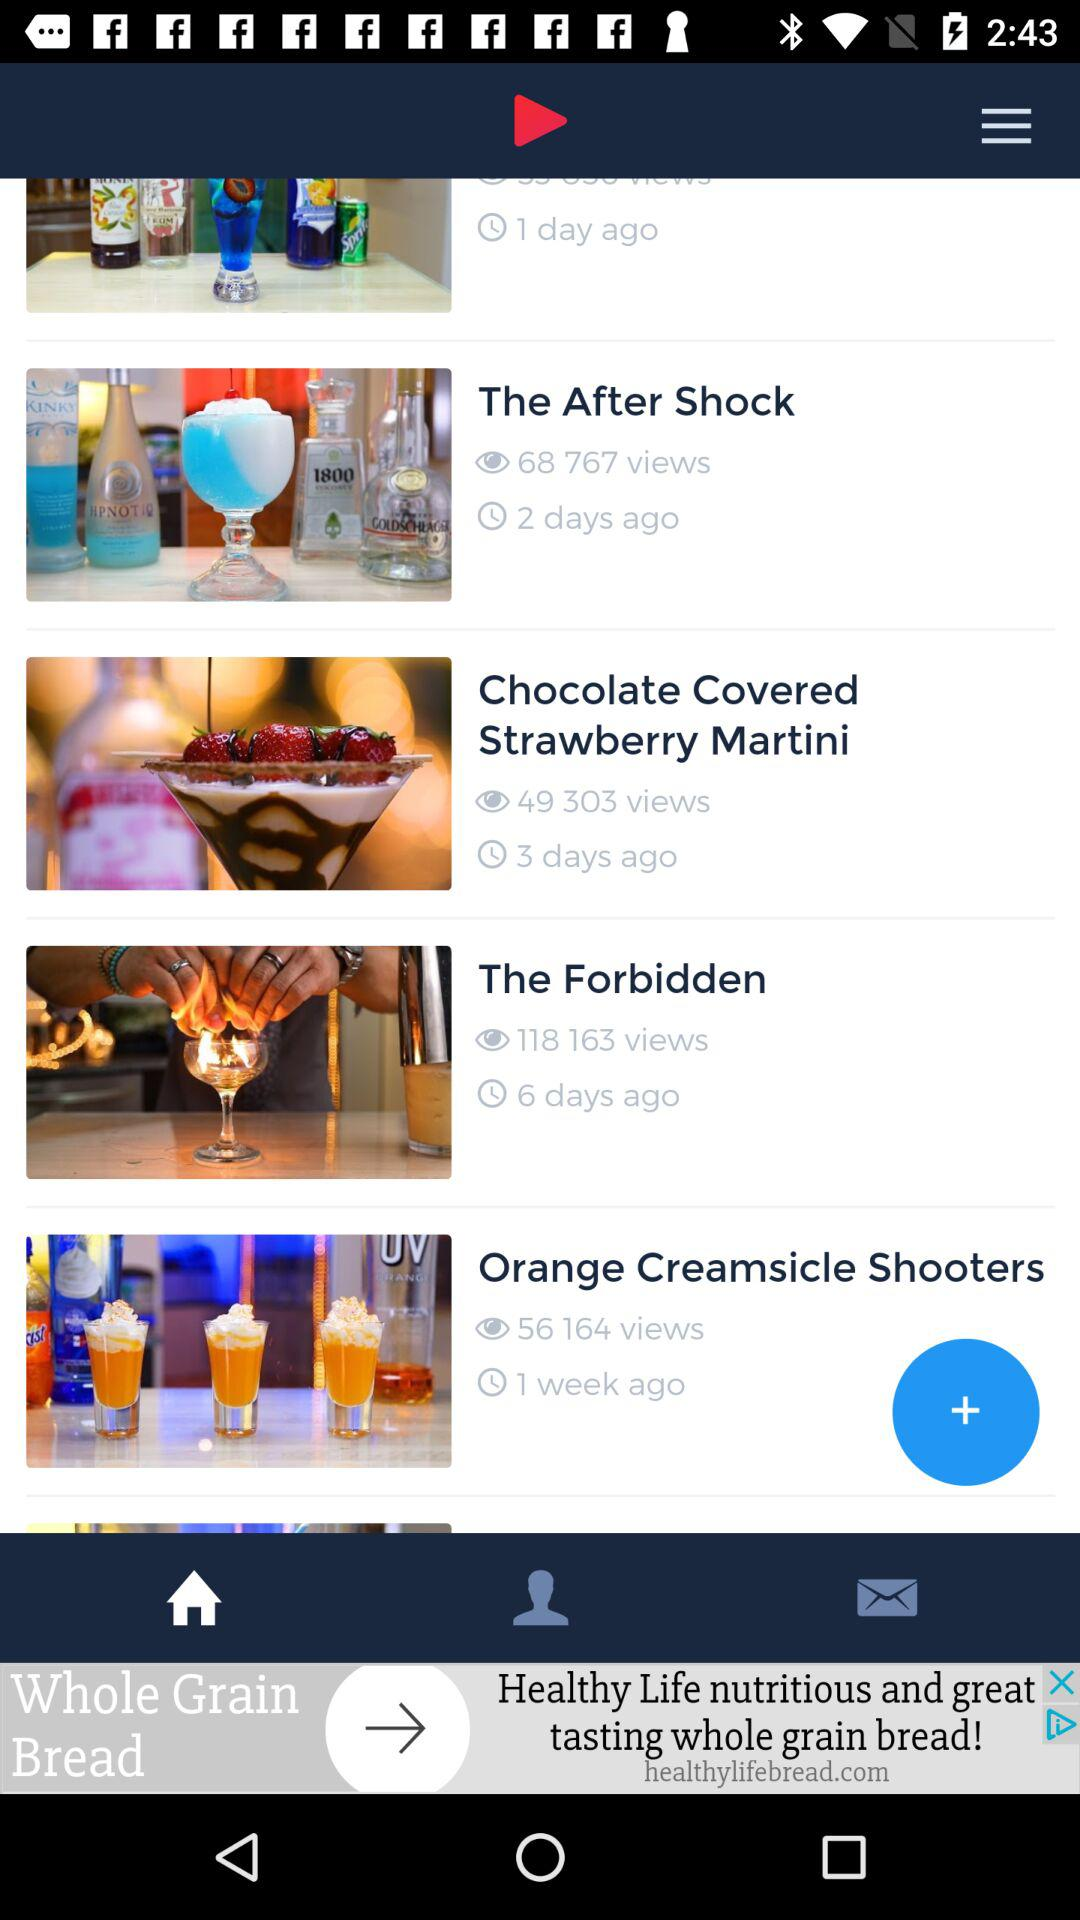How many views are there of the video "Orange Creamsicle Shooters"? There are 56,164 views. 